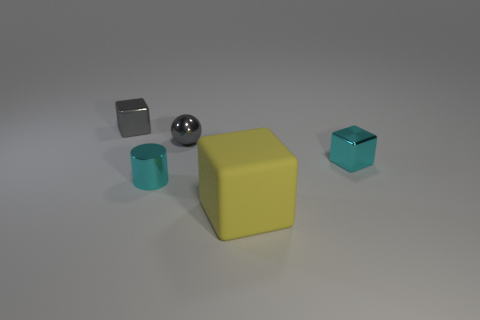What do you think is the context or purpose of these objects being grouped together? These objects appear to be arranged for a visual study, possibly to compare and contrast shapes, colors, and textures. The variety among the objects suggests a controlled setup perhaps designed for an educational purpose, artistic composition, or a material study. 